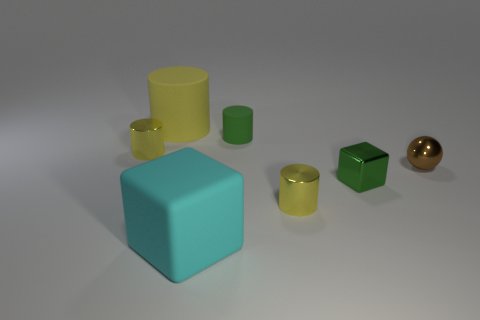Subtract all purple balls. How many yellow cylinders are left? 3 Subtract all yellow cylinders. How many cylinders are left? 1 Subtract 1 cylinders. How many cylinders are left? 3 Subtract all green cylinders. How many cylinders are left? 3 Subtract all purple cylinders. Subtract all brown balls. How many cylinders are left? 4 Add 2 red metallic cylinders. How many objects exist? 9 Subtract all blocks. How many objects are left? 5 Subtract 0 brown cylinders. How many objects are left? 7 Subtract all spheres. Subtract all large cyan matte cubes. How many objects are left? 5 Add 1 small green rubber cylinders. How many small green rubber cylinders are left? 2 